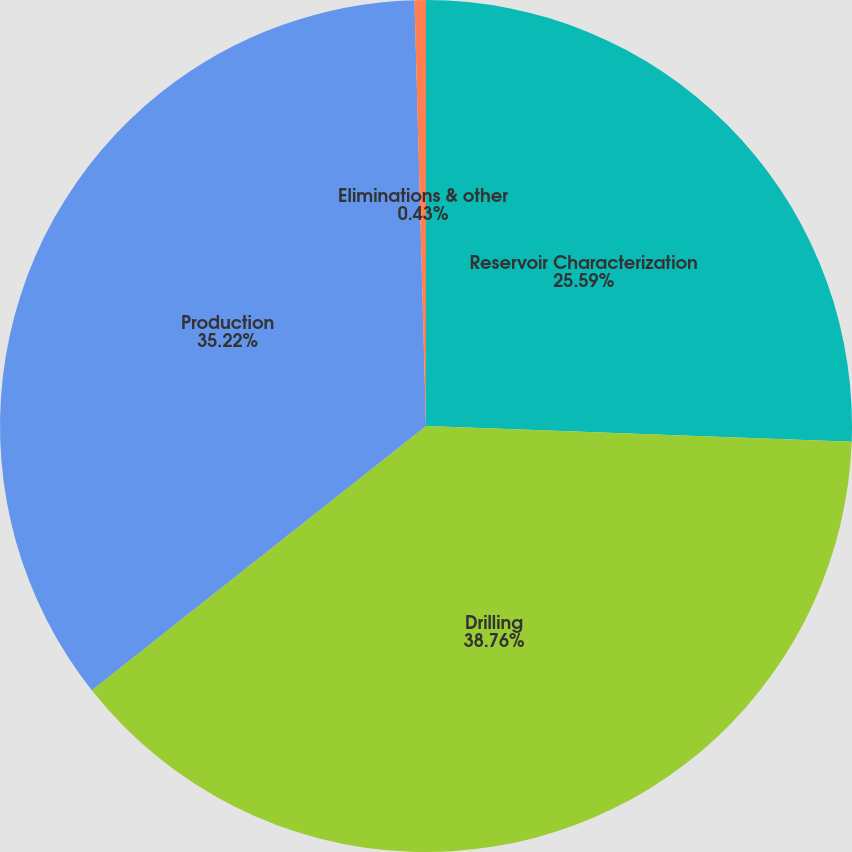<chart> <loc_0><loc_0><loc_500><loc_500><pie_chart><fcel>Reservoir Characterization<fcel>Drilling<fcel>Production<fcel>Eliminations & other<nl><fcel>25.59%<fcel>38.77%<fcel>35.22%<fcel>0.43%<nl></chart> 